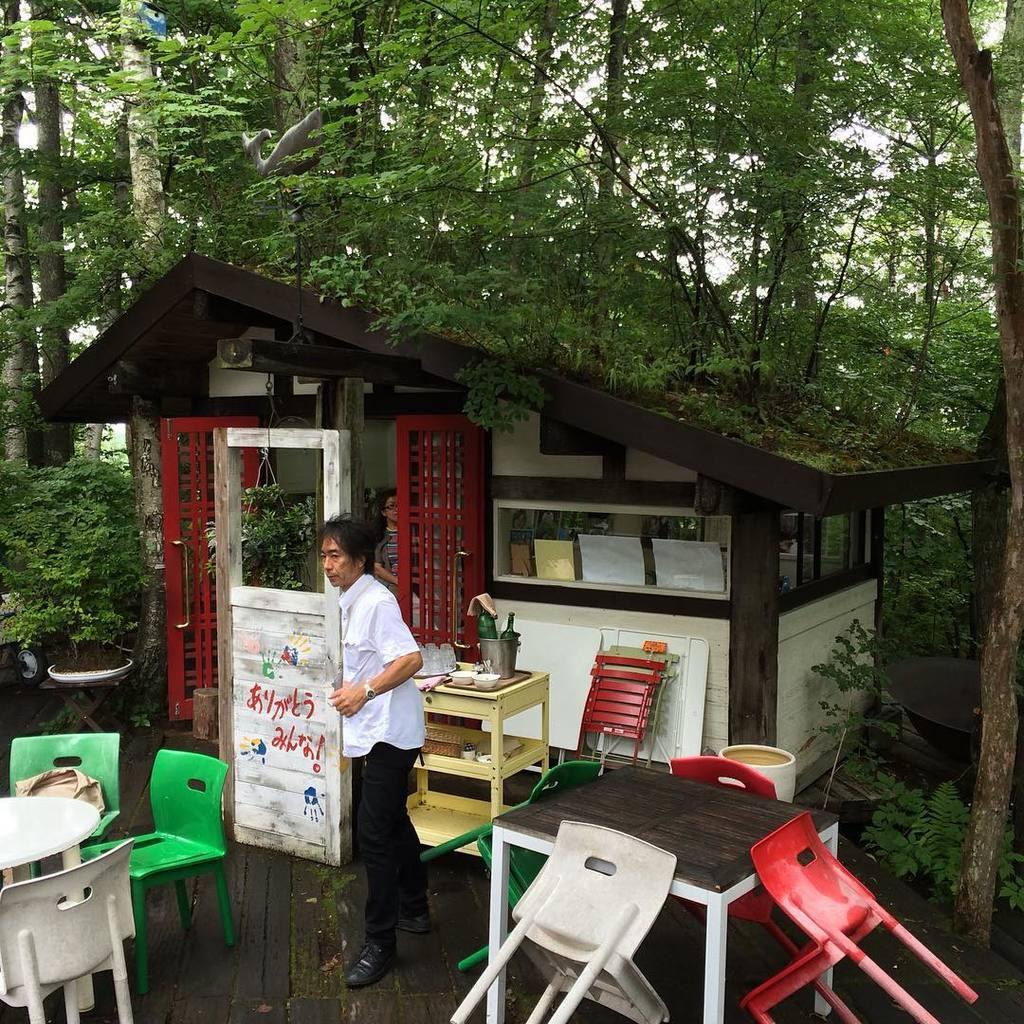In one or two sentences, can you explain what this image depicts? This image consists of trees at the top. There is some store in the middle. There is a person standing in the middle. There are tables and chairs at the bottom. 